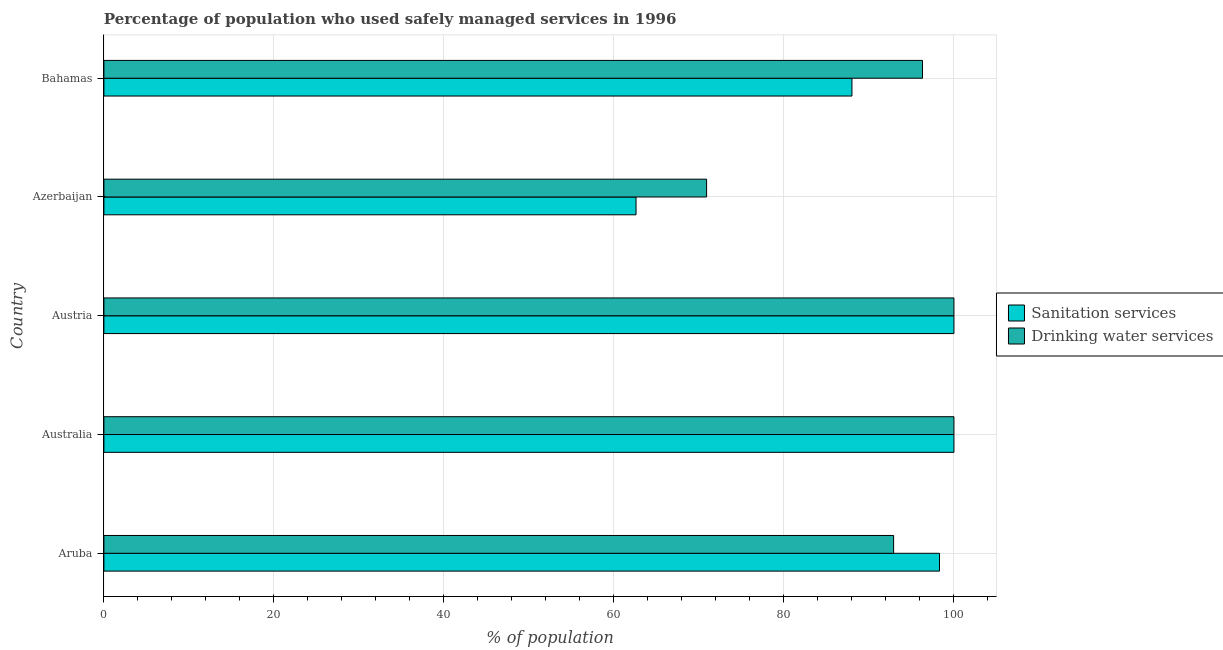How many different coloured bars are there?
Provide a succinct answer. 2. How many groups of bars are there?
Give a very brief answer. 5. Are the number of bars per tick equal to the number of legend labels?
Give a very brief answer. Yes. Are the number of bars on each tick of the Y-axis equal?
Ensure brevity in your answer.  Yes. What is the percentage of population who used drinking water services in Azerbaijan?
Your answer should be compact. 70.9. Across all countries, what is the minimum percentage of population who used sanitation services?
Give a very brief answer. 62.6. In which country was the percentage of population who used sanitation services maximum?
Ensure brevity in your answer.  Australia. In which country was the percentage of population who used sanitation services minimum?
Offer a terse response. Azerbaijan. What is the total percentage of population who used sanitation services in the graph?
Ensure brevity in your answer.  448.9. What is the difference between the percentage of population who used drinking water services in Austria and that in Azerbaijan?
Your answer should be very brief. 29.1. What is the difference between the percentage of population who used sanitation services in Australia and the percentage of population who used drinking water services in Azerbaijan?
Offer a very short reply. 29.1. What is the average percentage of population who used drinking water services per country?
Make the answer very short. 92.02. What is the ratio of the percentage of population who used drinking water services in Aruba to that in Azerbaijan?
Provide a succinct answer. 1.31. Is the difference between the percentage of population who used sanitation services in Austria and Azerbaijan greater than the difference between the percentage of population who used drinking water services in Austria and Azerbaijan?
Make the answer very short. Yes. What is the difference between the highest and the lowest percentage of population who used drinking water services?
Ensure brevity in your answer.  29.1. In how many countries, is the percentage of population who used drinking water services greater than the average percentage of population who used drinking water services taken over all countries?
Give a very brief answer. 4. What does the 2nd bar from the top in Azerbaijan represents?
Offer a very short reply. Sanitation services. What does the 2nd bar from the bottom in Aruba represents?
Give a very brief answer. Drinking water services. How many bars are there?
Provide a short and direct response. 10. How many countries are there in the graph?
Your answer should be very brief. 5. What is the difference between two consecutive major ticks on the X-axis?
Offer a very short reply. 20. Are the values on the major ticks of X-axis written in scientific E-notation?
Make the answer very short. No. Does the graph contain any zero values?
Offer a terse response. No. How many legend labels are there?
Offer a very short reply. 2. How are the legend labels stacked?
Your answer should be compact. Vertical. What is the title of the graph?
Make the answer very short. Percentage of population who used safely managed services in 1996. What is the label or title of the X-axis?
Keep it short and to the point. % of population. What is the label or title of the Y-axis?
Provide a short and direct response. Country. What is the % of population in Sanitation services in Aruba?
Offer a terse response. 98.3. What is the % of population of Drinking water services in Aruba?
Provide a succinct answer. 92.9. What is the % of population of Drinking water services in Australia?
Provide a short and direct response. 100. What is the % of population in Sanitation services in Austria?
Keep it short and to the point. 100. What is the % of population of Sanitation services in Azerbaijan?
Your response must be concise. 62.6. What is the % of population of Drinking water services in Azerbaijan?
Provide a succinct answer. 70.9. What is the % of population in Drinking water services in Bahamas?
Make the answer very short. 96.3. Across all countries, what is the minimum % of population in Sanitation services?
Your answer should be very brief. 62.6. Across all countries, what is the minimum % of population of Drinking water services?
Keep it short and to the point. 70.9. What is the total % of population of Sanitation services in the graph?
Your answer should be compact. 448.9. What is the total % of population of Drinking water services in the graph?
Make the answer very short. 460.1. What is the difference between the % of population of Sanitation services in Aruba and that in Australia?
Give a very brief answer. -1.7. What is the difference between the % of population of Drinking water services in Aruba and that in Australia?
Keep it short and to the point. -7.1. What is the difference between the % of population of Drinking water services in Aruba and that in Austria?
Give a very brief answer. -7.1. What is the difference between the % of population in Sanitation services in Aruba and that in Azerbaijan?
Offer a terse response. 35.7. What is the difference between the % of population of Drinking water services in Aruba and that in Azerbaijan?
Offer a very short reply. 22. What is the difference between the % of population in Drinking water services in Aruba and that in Bahamas?
Provide a succinct answer. -3.4. What is the difference between the % of population of Sanitation services in Australia and that in Azerbaijan?
Provide a succinct answer. 37.4. What is the difference between the % of population in Drinking water services in Australia and that in Azerbaijan?
Your answer should be very brief. 29.1. What is the difference between the % of population in Sanitation services in Australia and that in Bahamas?
Keep it short and to the point. 12. What is the difference between the % of population of Drinking water services in Australia and that in Bahamas?
Make the answer very short. 3.7. What is the difference between the % of population of Sanitation services in Austria and that in Azerbaijan?
Give a very brief answer. 37.4. What is the difference between the % of population of Drinking water services in Austria and that in Azerbaijan?
Keep it short and to the point. 29.1. What is the difference between the % of population in Sanitation services in Azerbaijan and that in Bahamas?
Your answer should be very brief. -25.4. What is the difference between the % of population in Drinking water services in Azerbaijan and that in Bahamas?
Provide a succinct answer. -25.4. What is the difference between the % of population of Sanitation services in Aruba and the % of population of Drinking water services in Austria?
Keep it short and to the point. -1.7. What is the difference between the % of population of Sanitation services in Aruba and the % of population of Drinking water services in Azerbaijan?
Your answer should be compact. 27.4. What is the difference between the % of population in Sanitation services in Australia and the % of population in Drinking water services in Austria?
Offer a terse response. 0. What is the difference between the % of population in Sanitation services in Australia and the % of population in Drinking water services in Azerbaijan?
Your answer should be compact. 29.1. What is the difference between the % of population in Sanitation services in Austria and the % of population in Drinking water services in Azerbaijan?
Make the answer very short. 29.1. What is the difference between the % of population in Sanitation services in Austria and the % of population in Drinking water services in Bahamas?
Offer a terse response. 3.7. What is the difference between the % of population in Sanitation services in Azerbaijan and the % of population in Drinking water services in Bahamas?
Give a very brief answer. -33.7. What is the average % of population in Sanitation services per country?
Offer a terse response. 89.78. What is the average % of population in Drinking water services per country?
Offer a very short reply. 92.02. What is the difference between the % of population in Sanitation services and % of population in Drinking water services in Australia?
Offer a terse response. 0. What is the ratio of the % of population of Drinking water services in Aruba to that in Australia?
Keep it short and to the point. 0.93. What is the ratio of the % of population in Drinking water services in Aruba to that in Austria?
Provide a succinct answer. 0.93. What is the ratio of the % of population in Sanitation services in Aruba to that in Azerbaijan?
Offer a very short reply. 1.57. What is the ratio of the % of population of Drinking water services in Aruba to that in Azerbaijan?
Ensure brevity in your answer.  1.31. What is the ratio of the % of population of Sanitation services in Aruba to that in Bahamas?
Provide a succinct answer. 1.12. What is the ratio of the % of population in Drinking water services in Aruba to that in Bahamas?
Ensure brevity in your answer.  0.96. What is the ratio of the % of population of Sanitation services in Australia to that in Azerbaijan?
Offer a very short reply. 1.6. What is the ratio of the % of population in Drinking water services in Australia to that in Azerbaijan?
Your response must be concise. 1.41. What is the ratio of the % of population of Sanitation services in Australia to that in Bahamas?
Offer a terse response. 1.14. What is the ratio of the % of population in Drinking water services in Australia to that in Bahamas?
Keep it short and to the point. 1.04. What is the ratio of the % of population in Sanitation services in Austria to that in Azerbaijan?
Give a very brief answer. 1.6. What is the ratio of the % of population of Drinking water services in Austria to that in Azerbaijan?
Ensure brevity in your answer.  1.41. What is the ratio of the % of population in Sanitation services in Austria to that in Bahamas?
Your answer should be very brief. 1.14. What is the ratio of the % of population in Drinking water services in Austria to that in Bahamas?
Make the answer very short. 1.04. What is the ratio of the % of population in Sanitation services in Azerbaijan to that in Bahamas?
Your answer should be very brief. 0.71. What is the ratio of the % of population in Drinking water services in Azerbaijan to that in Bahamas?
Your response must be concise. 0.74. What is the difference between the highest and the lowest % of population in Sanitation services?
Your answer should be very brief. 37.4. What is the difference between the highest and the lowest % of population in Drinking water services?
Offer a terse response. 29.1. 